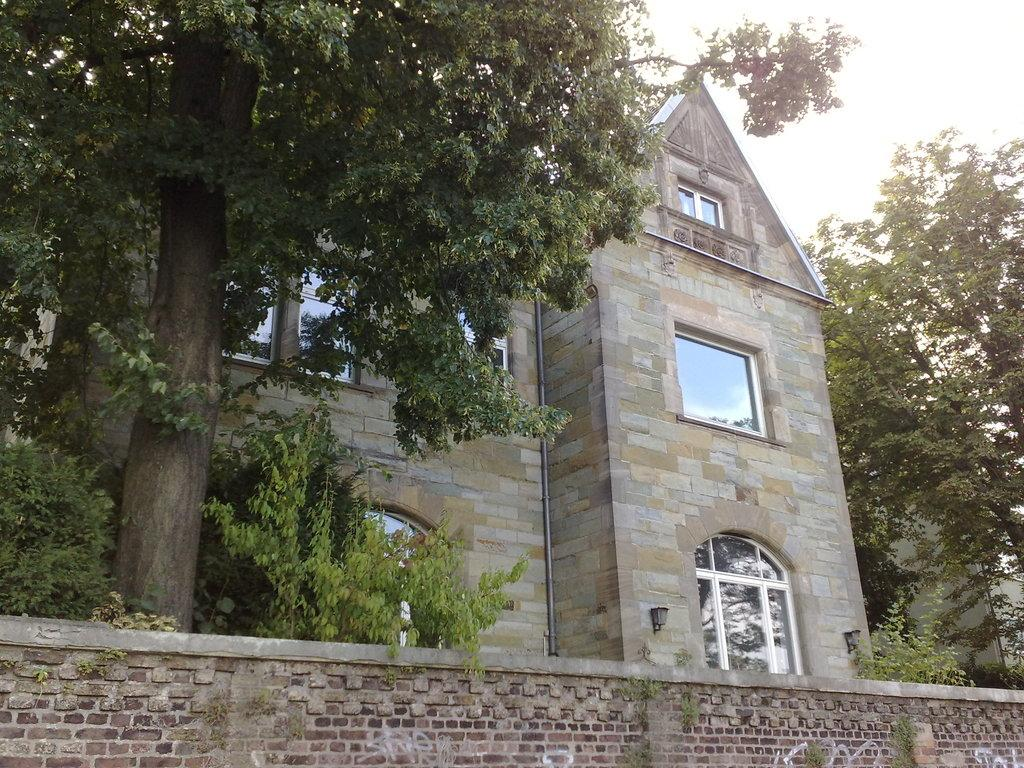What is located at the bottom of the image? There is a wall at the bottom of the image. What can be seen in the middle of the image? There are trees and a building in the middle of the image. What is visible in the background of the image? The sky is visible in the background of the image. How many dimes are scattered around the scarecrow in the image? There is no scarecrow or dimes present in the image. Can you tell me which direction the trees are facing in the image? The provided facts do not specify the direction the trees are facing, so it cannot be determined from the image. 